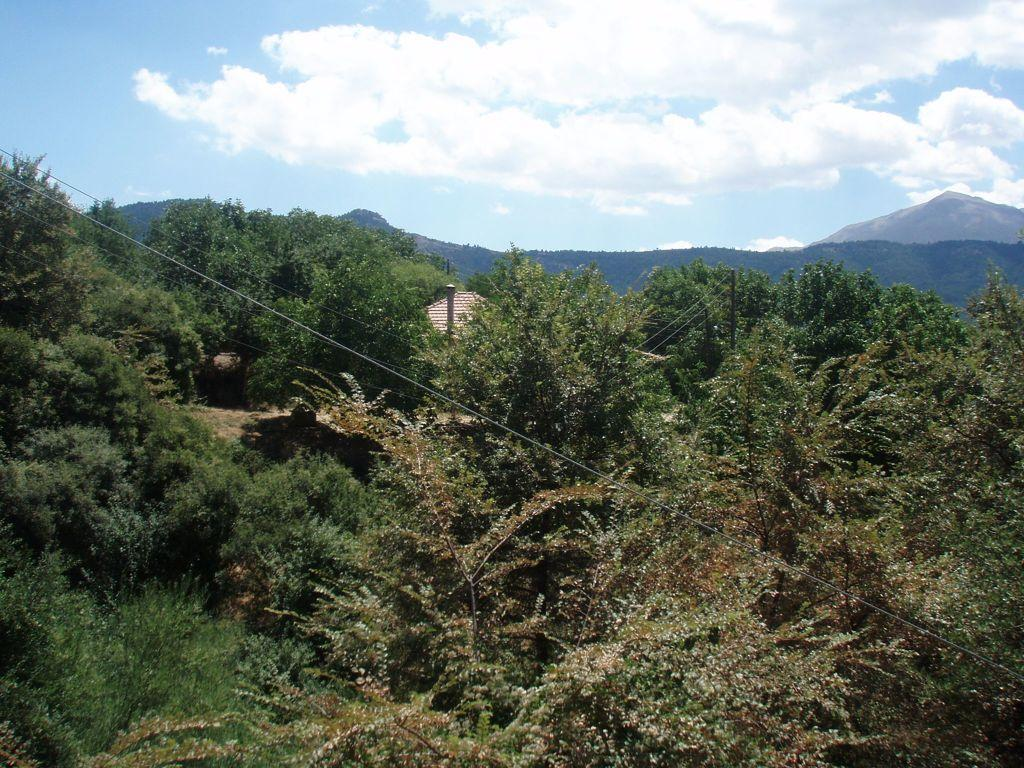What type of vegetation can be seen in the image? There are trees in the image. What is visible in the background of the image? The sky is visible in the image. What can be observed in the sky? Clouds are present in the sky. What type of light source is illuminating the trees in the image? There is no specific light source mentioned or visible in the image, as it appears to be a natural scene with sunlight. 